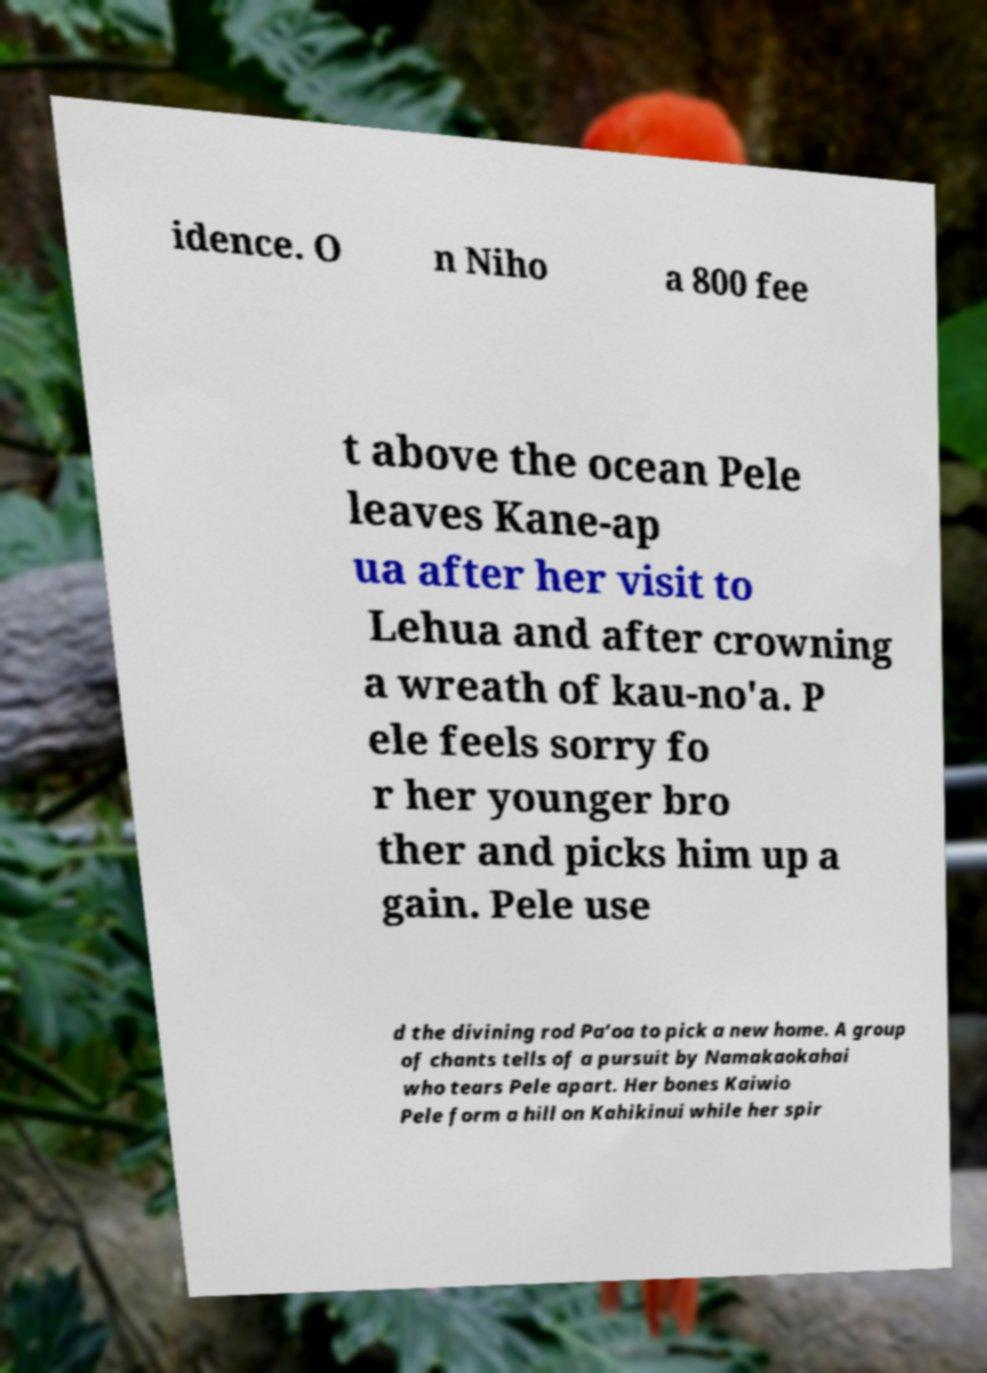Please read and relay the text visible in this image. What does it say? idence. O n Niho a 800 fee t above the ocean Pele leaves Kane-ap ua after her visit to Lehua and after crowning a wreath of kau-no'a. P ele feels sorry fo r her younger bro ther and picks him up a gain. Pele use d the divining rod Pa‘oa to pick a new home. A group of chants tells of a pursuit by Namakaokahai who tears Pele apart. Her bones Kaiwio Pele form a hill on Kahikinui while her spir 